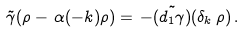Convert formula to latex. <formula><loc_0><loc_0><loc_500><loc_500>\tilde { \gamma } ( \rho - \, \alpha ( - k ) \rho ) = \, - \tilde { ( d _ { 1 } \gamma ) } ( \delta _ { k } \, \rho ) \, .</formula> 